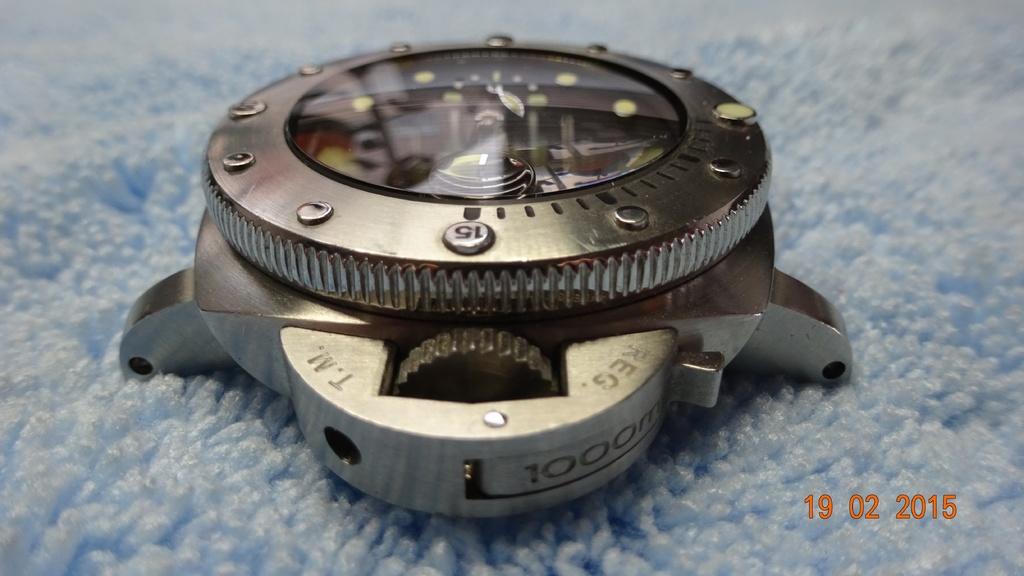What year was the photo taken?
Give a very brief answer. 2015. What number is on the side of this?
Make the answer very short. 1000. 